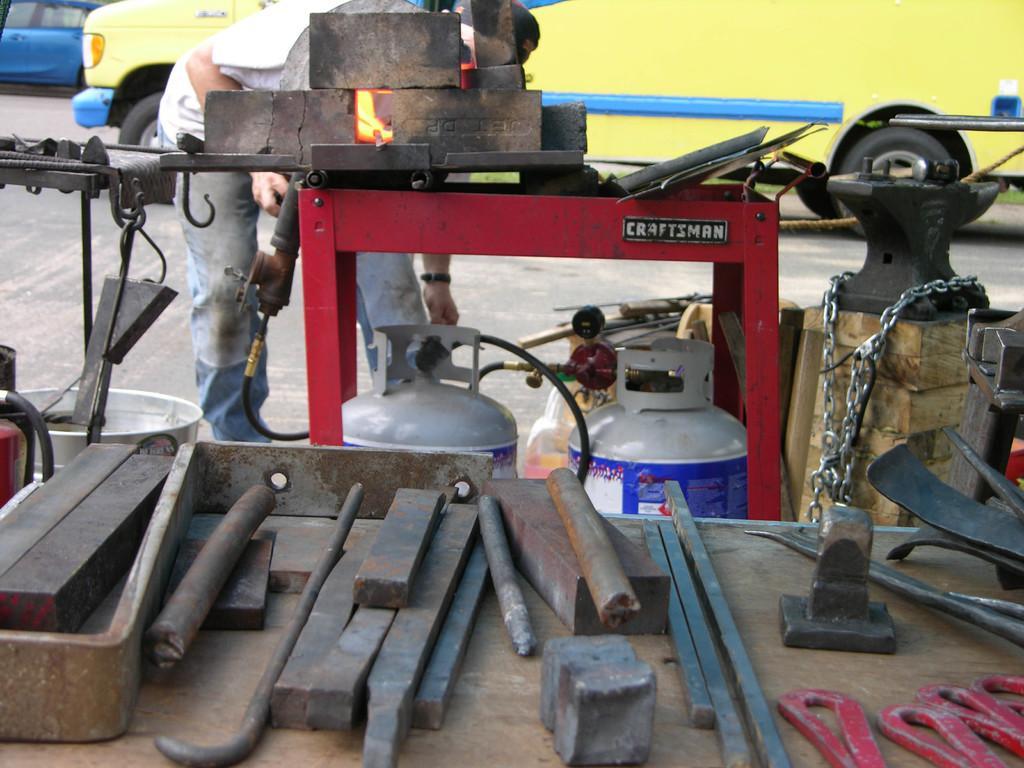Could you give a brief overview of what you see in this image? In this image in front there are metal tools on the table. In front of the table there are two cylinders and a gas stove. In front of the gas stove there is a person operating the stove. On the backside there are two cars parked on the road. 